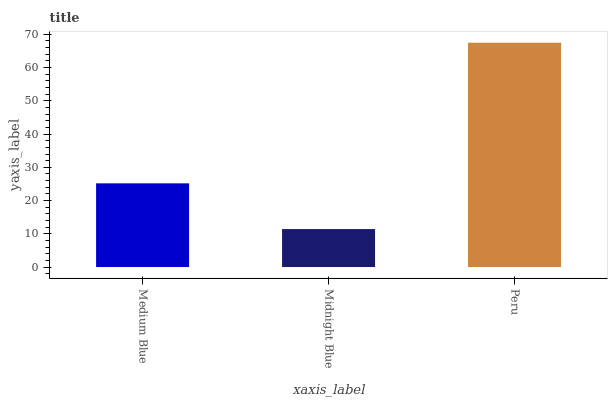Is Midnight Blue the minimum?
Answer yes or no. Yes. Is Peru the maximum?
Answer yes or no. Yes. Is Peru the minimum?
Answer yes or no. No. Is Midnight Blue the maximum?
Answer yes or no. No. Is Peru greater than Midnight Blue?
Answer yes or no. Yes. Is Midnight Blue less than Peru?
Answer yes or no. Yes. Is Midnight Blue greater than Peru?
Answer yes or no. No. Is Peru less than Midnight Blue?
Answer yes or no. No. Is Medium Blue the high median?
Answer yes or no. Yes. Is Medium Blue the low median?
Answer yes or no. Yes. Is Midnight Blue the high median?
Answer yes or no. No. Is Peru the low median?
Answer yes or no. No. 